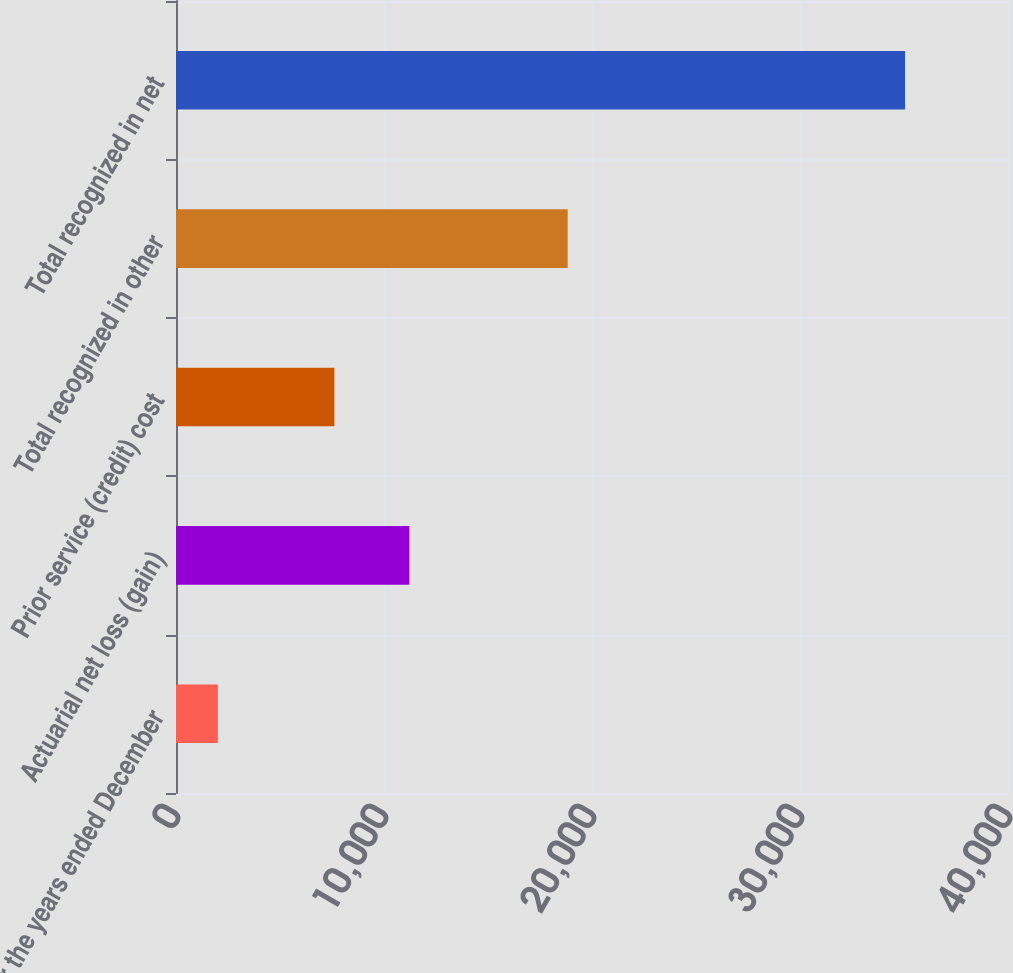<chart> <loc_0><loc_0><loc_500><loc_500><bar_chart><fcel>For the years ended December<fcel>Actuarial net loss (gain)<fcel>Prior service (credit) cost<fcel>Total recognized in other<fcel>Total recognized in net<nl><fcel>2011<fcel>11216<fcel>7614<fcel>18830<fcel>35048<nl></chart> 